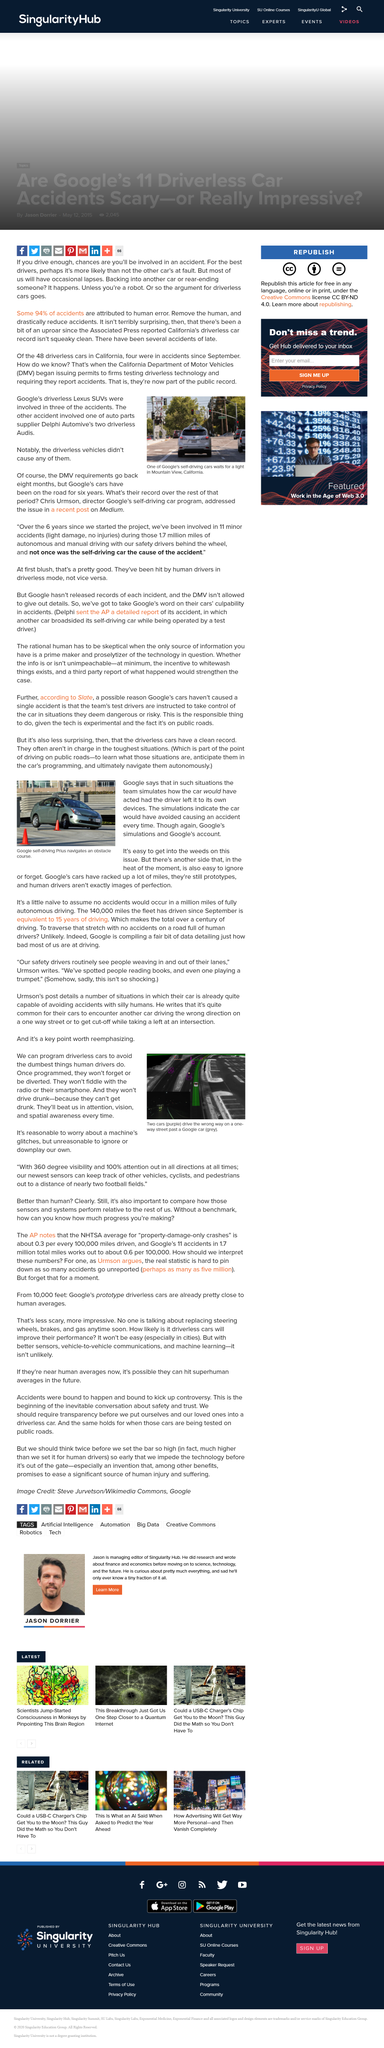Outline some significant characteristics in this image. It is a well-known fact that Google, a leading internet company, manufactures driverless cars. Driverless cars outperform humans in attention, vision, and spatial awareness. Four of the 48 driverless cars operating in California were involved in accidents. The California Department of Motor Vehicles requires firms testing driverless cars to report any accidents that occur during testing. The image depicts a Google self-driving Prius successfully navigating an obstacle course. 